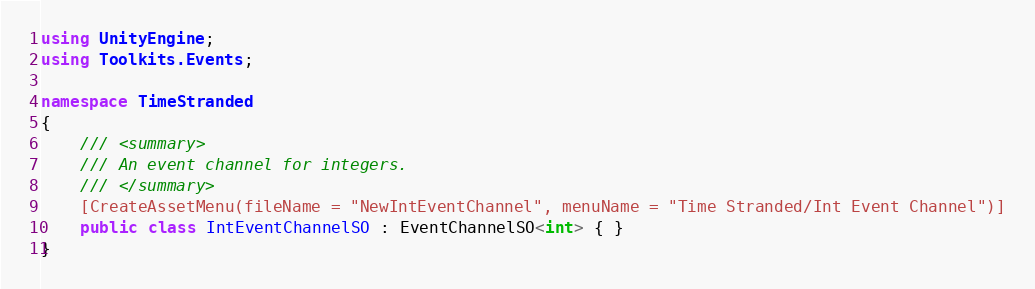<code> <loc_0><loc_0><loc_500><loc_500><_C#_>using UnityEngine;
using Toolkits.Events;

namespace TimeStranded
{
    /// <summary>
    /// An event channel for integers.
    /// </summary>
    [CreateAssetMenu(fileName = "NewIntEventChannel", menuName = "Time Stranded/Int Event Channel")]
    public class IntEventChannelSO : EventChannelSO<int> { }
}
</code> 